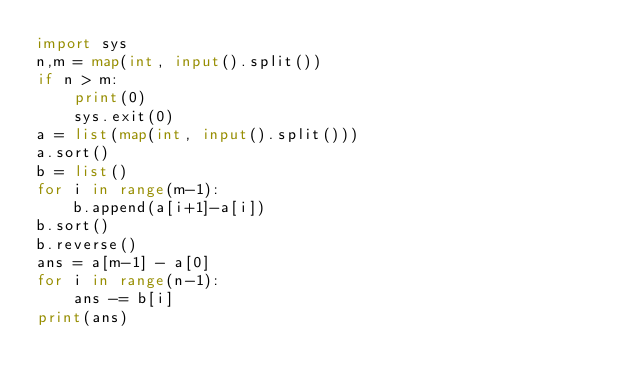Convert code to text. <code><loc_0><loc_0><loc_500><loc_500><_Python_>import sys
n,m = map(int, input().split())
if n > m:
    print(0)
    sys.exit(0)
a = list(map(int, input().split()))
a.sort()
b = list()
for i in range(m-1):
    b.append(a[i+1]-a[i])
b.sort()
b.reverse()
ans = a[m-1] - a[0]
for i in range(n-1):
    ans -= b[i]
print(ans)</code> 